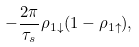<formula> <loc_0><loc_0><loc_500><loc_500>- \frac { 2 \pi } { \tau _ { s } } \rho _ { 1 \downarrow } ( 1 - \rho _ { 1 \uparrow } ) ,</formula> 